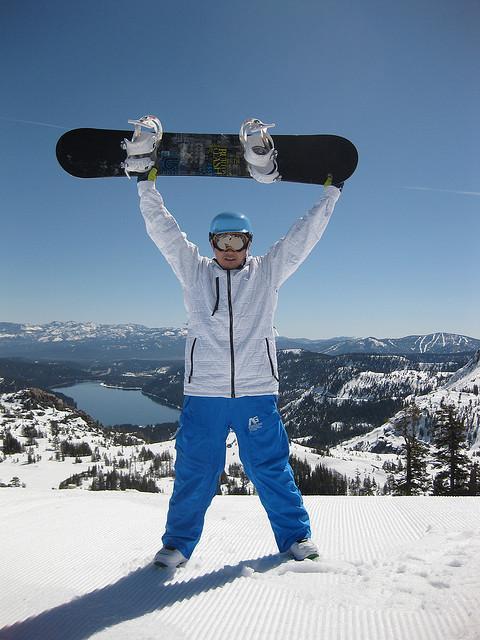How many zebra are there?
Give a very brief answer. 0. 